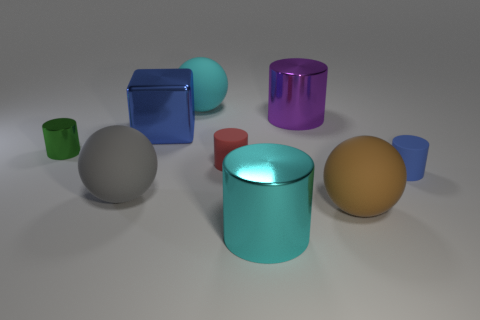What materials appear to be represented by the objects in the image? The objects in the image seem to represent materials with a metallic sheen and opaque surfaces, likely suggesting metals or plastics with varying reflective properties. 